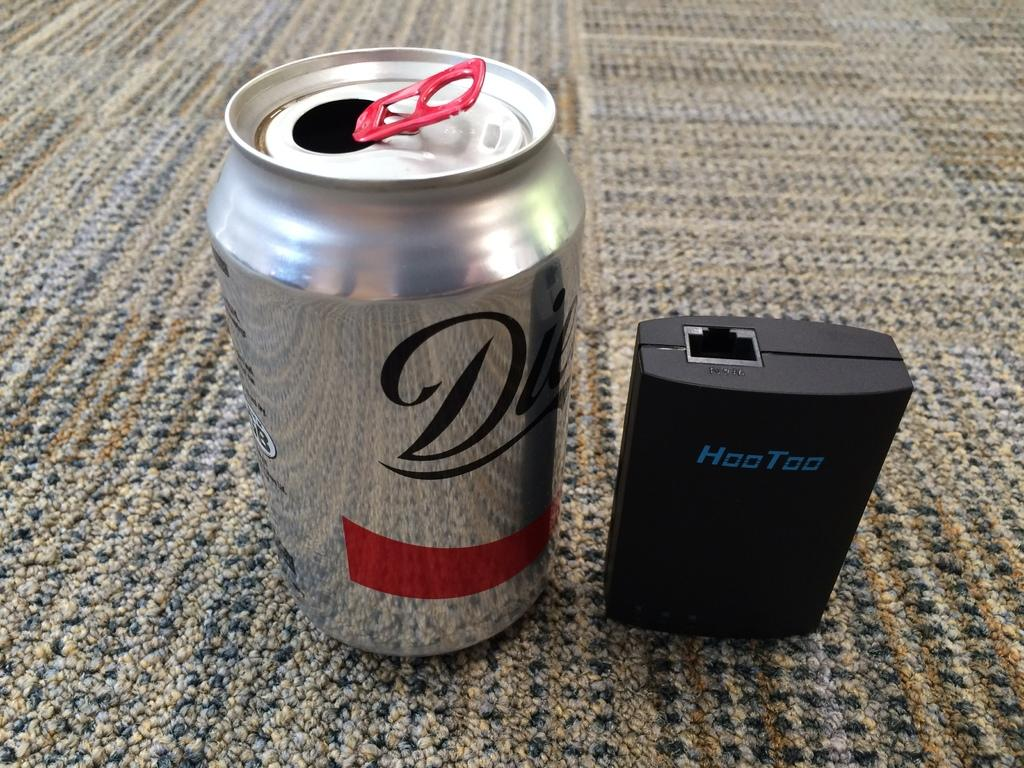<image>
Summarize the visual content of the image. one open silver color can with Letter D on it and Hoo Too charger beside it 